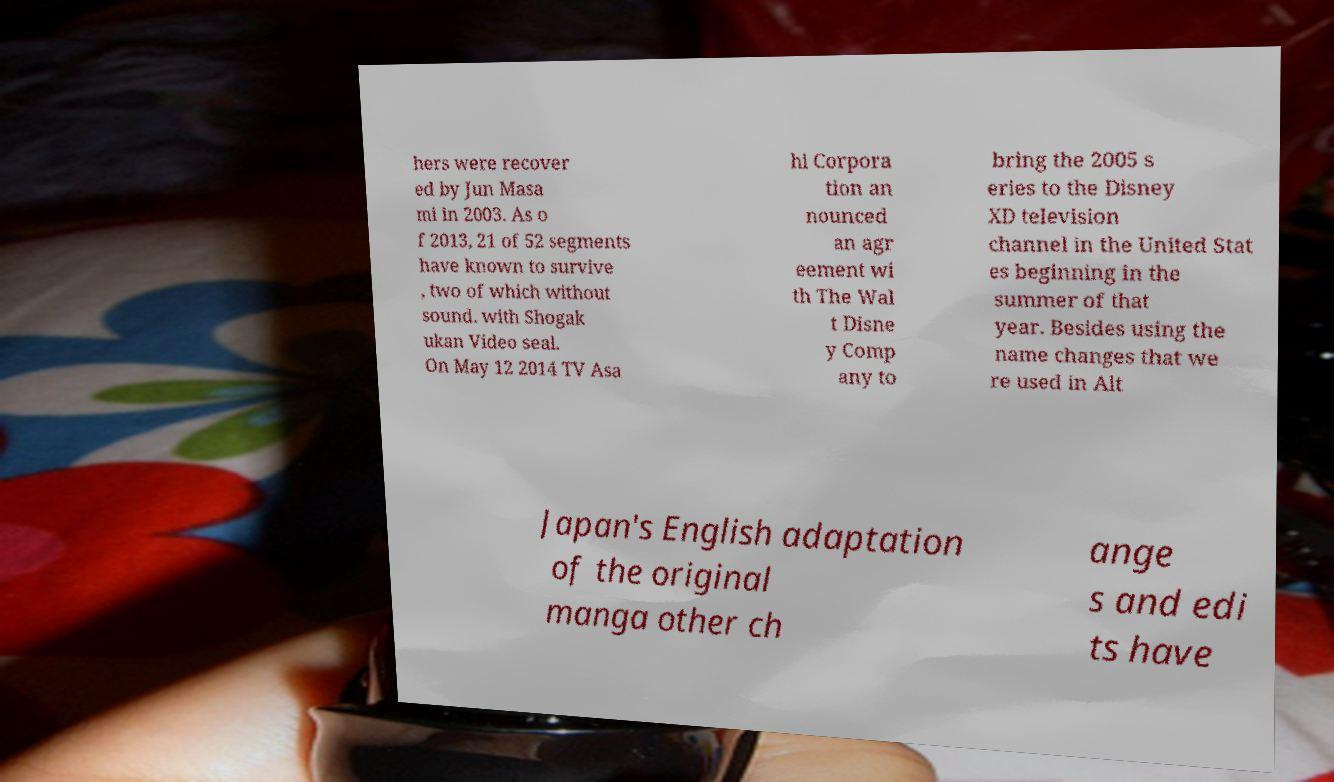Can you read and provide the text displayed in the image?This photo seems to have some interesting text. Can you extract and type it out for me? hers were recover ed by Jun Masa mi in 2003. As o f 2013, 21 of 52 segments have known to survive , two of which without sound. with Shogak ukan Video seal. On May 12 2014 TV Asa hi Corpora tion an nounced an agr eement wi th The Wal t Disne y Comp any to bring the 2005 s eries to the Disney XD television channel in the United Stat es beginning in the summer of that year. Besides using the name changes that we re used in Alt Japan's English adaptation of the original manga other ch ange s and edi ts have 